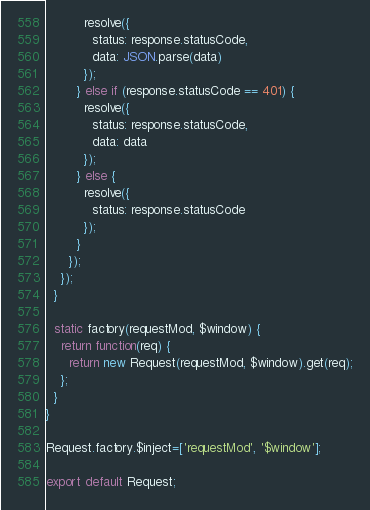Convert code to text. <code><loc_0><loc_0><loc_500><loc_500><_JavaScript_>          resolve({
            status: response.statusCode,
            data: JSON.parse(data)
          });
        } else if (response.statusCode == 401) {
          resolve({
            status: response.statusCode,
            data: data
          });
        } else {
          resolve({
            status: response.statusCode
          });
        }
      });
    });
  }

  static factory(requestMod, $window) {
    return function(req) {
      return new Request(requestMod, $window).get(req);
    };
  }
}

Request.factory.$inject=['requestMod', '$window'];

export default Request;
</code> 